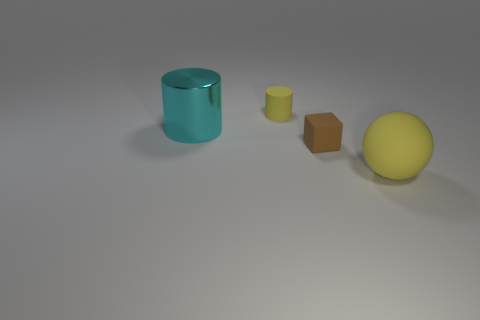Add 3 gray cylinders. How many objects exist? 7 Subtract all cubes. How many objects are left? 3 Add 1 small green matte cylinders. How many small green matte cylinders exist? 1 Subtract 0 cyan balls. How many objects are left? 4 Subtract all yellow rubber balls. Subtract all large matte balls. How many objects are left? 2 Add 4 brown blocks. How many brown blocks are left? 5 